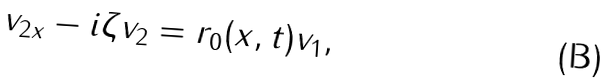<formula> <loc_0><loc_0><loc_500><loc_500>v _ { 2 x } - i \zeta v _ { 2 } = r _ { 0 } ( x , t ) v _ { 1 } ,</formula> 